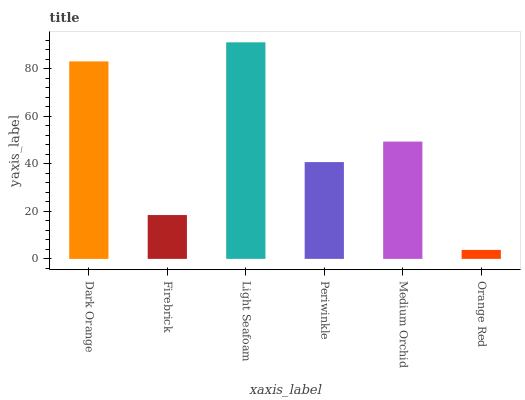Is Orange Red the minimum?
Answer yes or no. Yes. Is Light Seafoam the maximum?
Answer yes or no. Yes. Is Firebrick the minimum?
Answer yes or no. No. Is Firebrick the maximum?
Answer yes or no. No. Is Dark Orange greater than Firebrick?
Answer yes or no. Yes. Is Firebrick less than Dark Orange?
Answer yes or no. Yes. Is Firebrick greater than Dark Orange?
Answer yes or no. No. Is Dark Orange less than Firebrick?
Answer yes or no. No. Is Medium Orchid the high median?
Answer yes or no. Yes. Is Periwinkle the low median?
Answer yes or no. Yes. Is Periwinkle the high median?
Answer yes or no. No. Is Orange Red the low median?
Answer yes or no. No. 